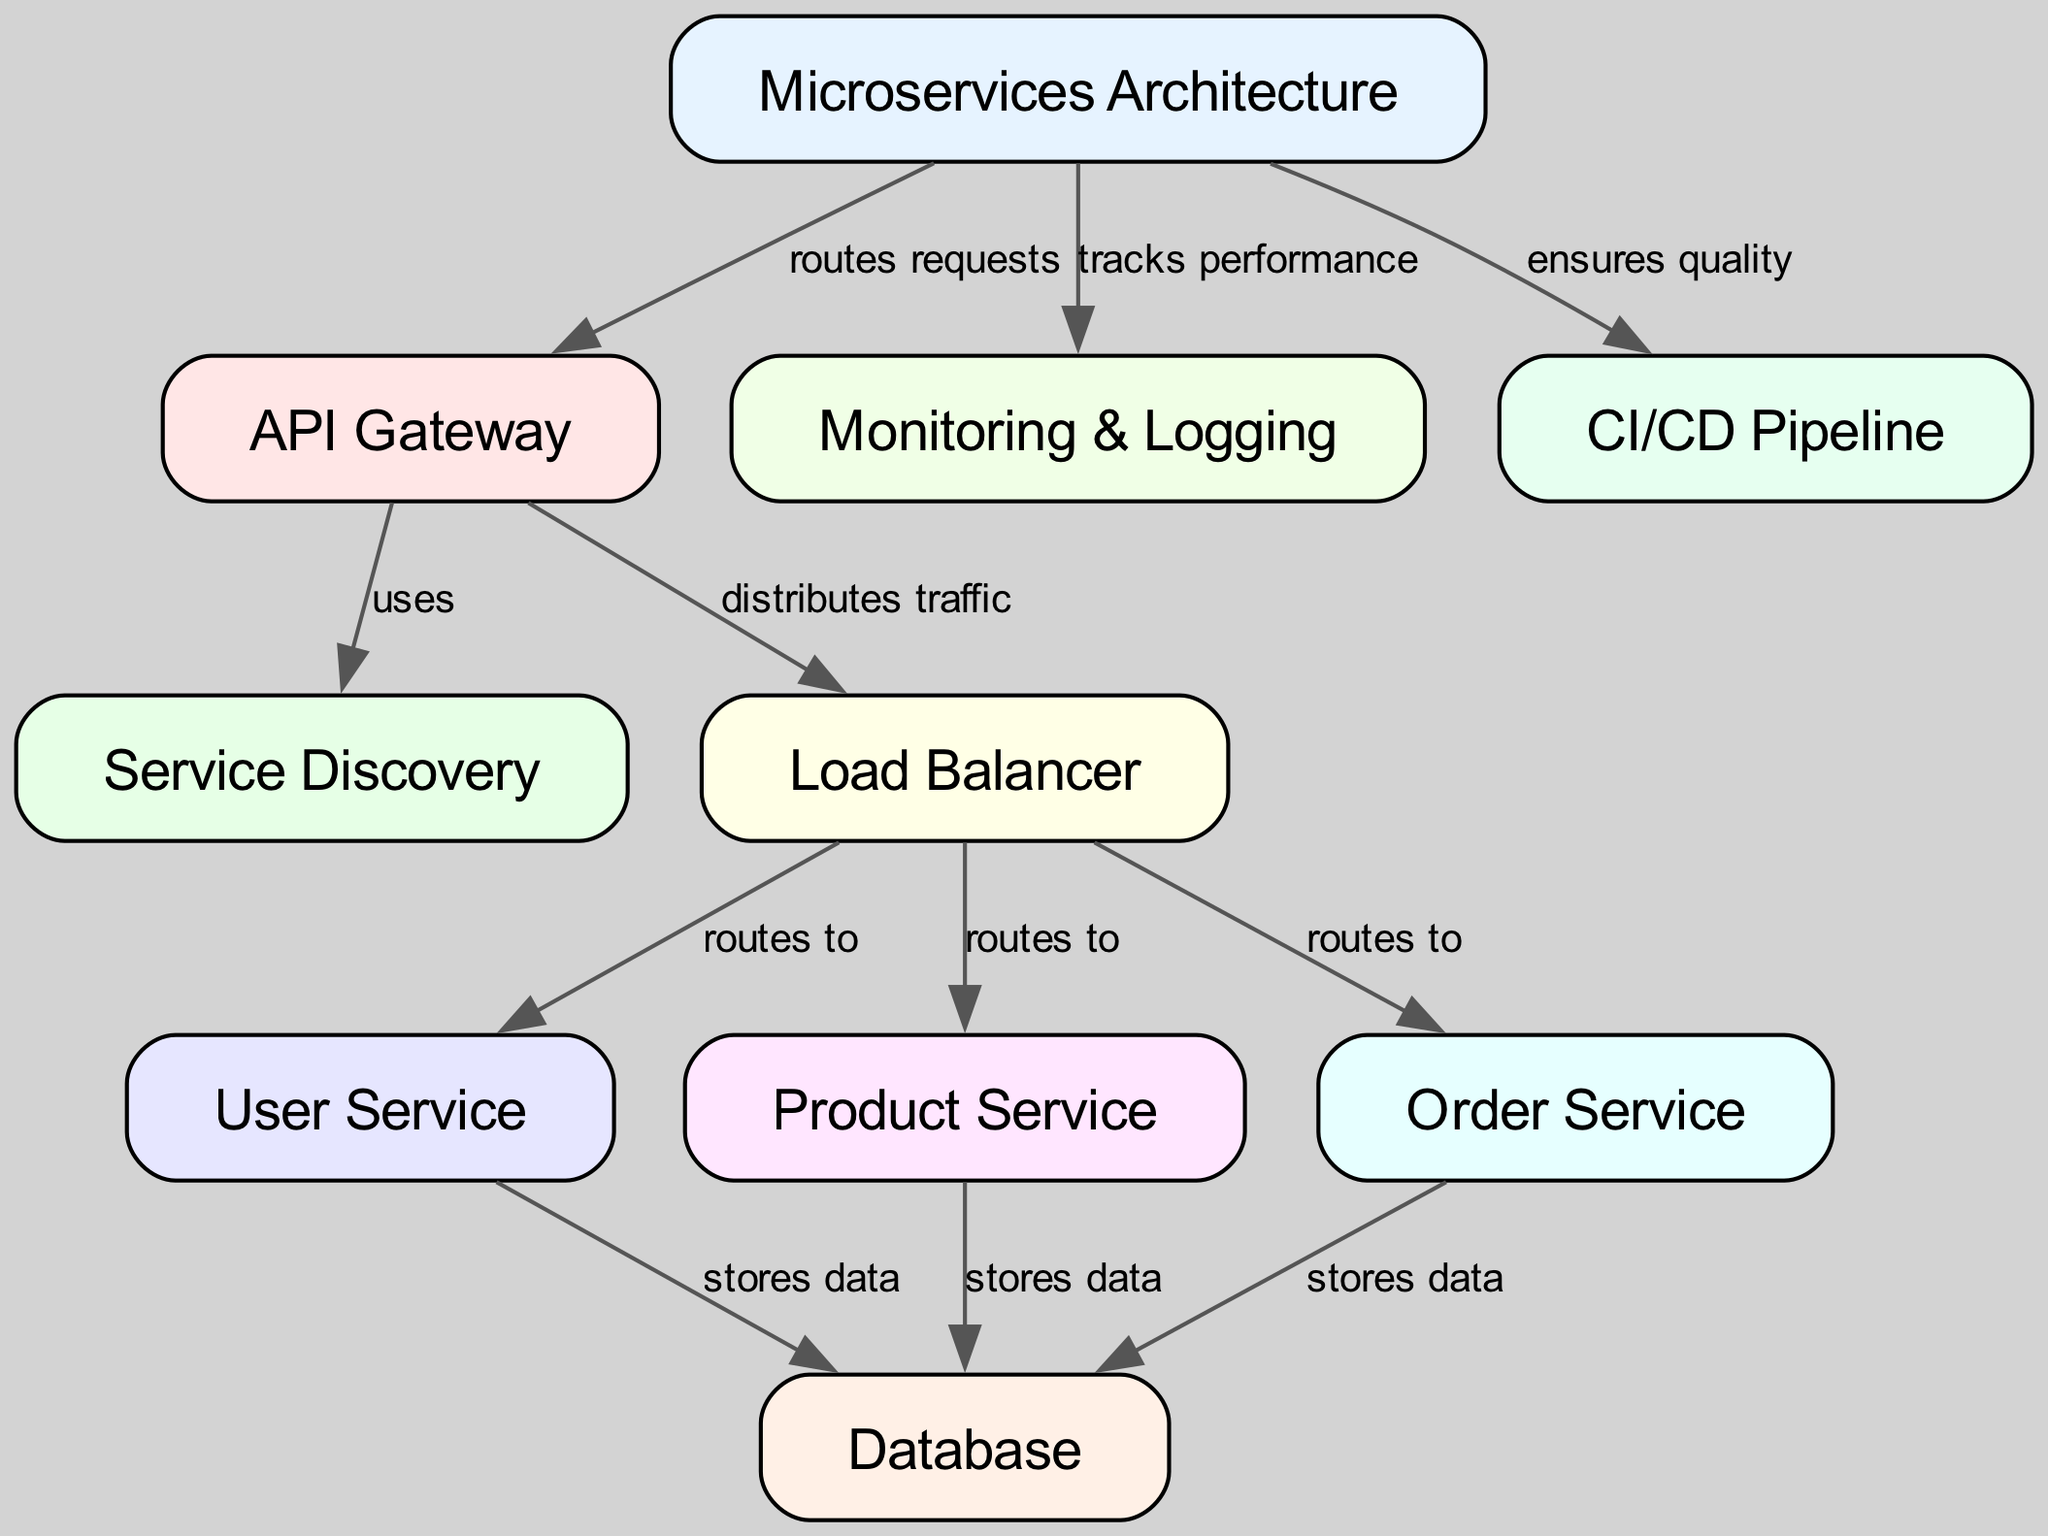What is the main architecture depicted in the diagram? The diagram represents a Microservices Architecture, as indicated by the main label at the top.
Answer: Microservices Architecture How many services are directly routed to by the Load Balancer? From the Load Balancer, there are three services: User Service, Product Service, and Order Service. These are the endpoints directly connected to it.
Answer: 3 What component uses Service Discovery? The API Gateway uses Service Discovery to find available service instances, which is shown by the directed edge in the diagram.
Answer: API Gateway Which service is responsible for storing data related to User functionality? The User Service is connected to the Database with the edge labeled 'stores data,' indicating its role in data management.
Answer: User Service How does the API Gateway distribute traffic? The API Gateway routes requests and distributes traffic to the Load Balancer, which then handles the request distribution among the underlying services.
Answer: Distributes traffic Which component tracks performance within the microservices architecture? Monitoring & Logging is the component responsible for tracking the performance of the microservices, as stated in the relationship depicted in the diagram.
Answer: Monitoring & Logging What ensures the quality of the microservices? The CI/CD Pipeline is responsible for ensuring quality within the microservices architecture, as indicated by its direct connection to the Microservices component in the diagram.
Answer: CI/CD Pipeline Which services have a direct connection to the Database? The services that connect to the Database are the User Service, Product Service, and Order Service, each indicated by their respective edges leading to the Database.
Answer: User Service, Product Service, Order Service How many edges are there in the diagram? Counting all the directed lines connecting the nodes gives a total of 10 edges, showing the relationships among the components.
Answer: 10 What is the purpose of the Load Balancer? The Load Balancer's purpose is to route traffic from the API Gateway to the specific services, ensuring efficient request handling.
Answer: Routes to services 